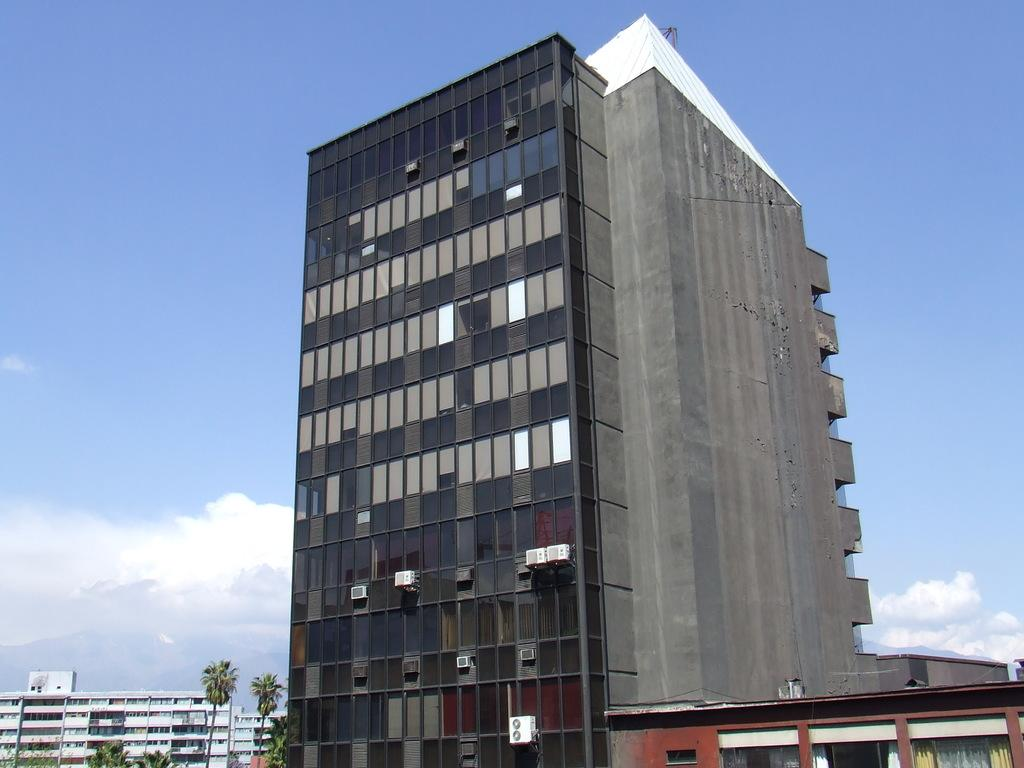What is the main subject of the image? The main subject of the image is a very big building. What can be seen on the left side of the image? There are trees on the left side of the image. What is visible at the top of the image? The sky is visible at the top of the image. What type of jeans is the bucket wearing in the image? There is no bucket or jeans present in the image. 